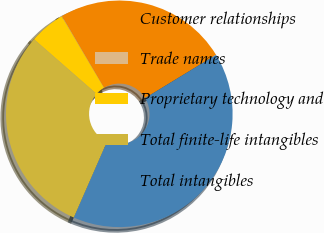<chart> <loc_0><loc_0><loc_500><loc_500><pie_chart><fcel>Customer relationships<fcel>Trade names<fcel>Proprietary technology and<fcel>Total finite-life intangibles<fcel>Total intangibles<nl><fcel>24.75%<fcel>0.04%<fcel>5.07%<fcel>29.86%<fcel>40.28%<nl></chart> 